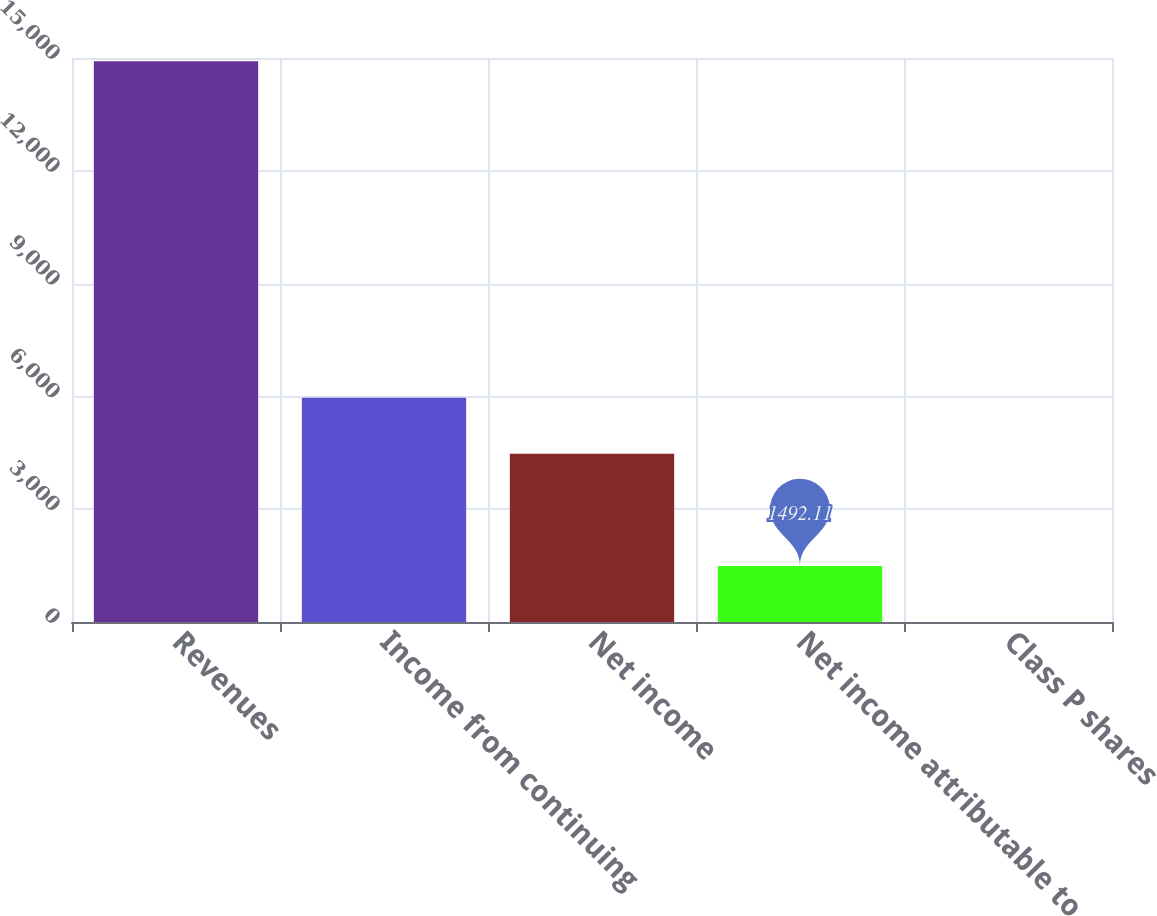<chart> <loc_0><loc_0><loc_500><loc_500><bar_chart><fcel>Revenues<fcel>Income from continuing<fcel>Net income<fcel>Net income attributable to<fcel>Class P shares<nl><fcel>14911<fcel>5965.08<fcel>4474.09<fcel>1492.11<fcel>1.12<nl></chart> 